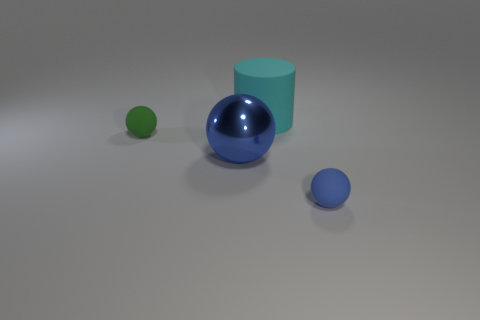Subtract all red cubes. How many blue balls are left? 2 Subtract all matte balls. How many balls are left? 1 Add 3 tiny green matte things. How many objects exist? 7 Subtract all yellow spheres. Subtract all green cylinders. How many spheres are left? 3 Subtract all cylinders. How many objects are left? 3 Add 3 blue matte spheres. How many blue matte spheres exist? 4 Subtract 0 red spheres. How many objects are left? 4 Subtract all blue matte objects. Subtract all metallic spheres. How many objects are left? 2 Add 4 big blue metallic spheres. How many big blue metallic spheres are left? 5 